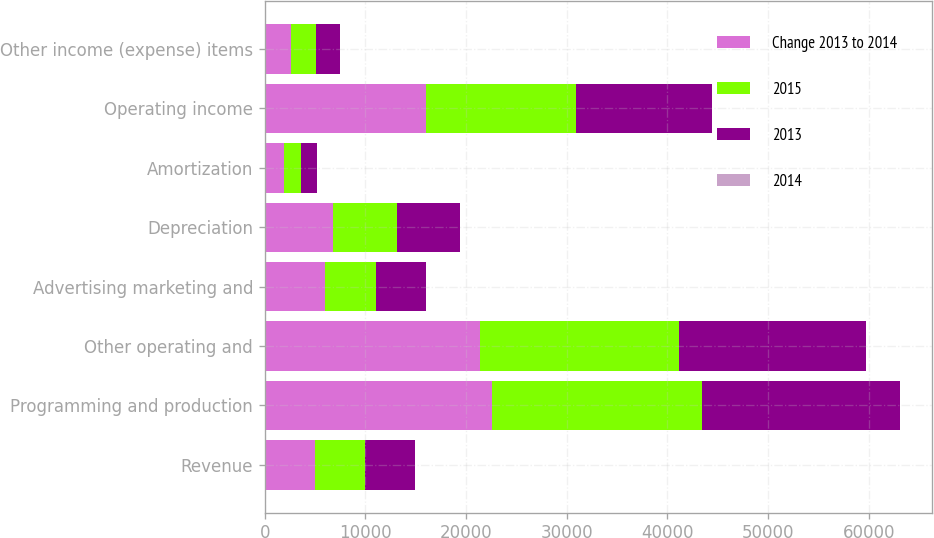Convert chart to OTSL. <chart><loc_0><loc_0><loc_500><loc_500><stacked_bar_chart><ecel><fcel>Revenue<fcel>Programming and production<fcel>Other operating and<fcel>Advertising marketing and<fcel>Depreciation<fcel>Amortization<fcel>Operating income<fcel>Other income (expense) items<nl><fcel>Change 2013 to 2014<fcel>4978<fcel>22550<fcel>21339<fcel>5943<fcel>6781<fcel>1899<fcel>15998<fcel>2626<nl><fcel>2015<fcel>4978<fcel>20912<fcel>19854<fcel>5086<fcel>6337<fcel>1682<fcel>14904<fcel>2439<nl><fcel>2013<fcel>4978<fcel>19670<fcel>18575<fcel>4978<fcel>6254<fcel>1617<fcel>13563<fcel>2448<nl><fcel>2014<fcel>8.3<fcel>7.8<fcel>7.5<fcel>16.8<fcel>7<fcel>12.8<fcel>7.3<fcel>7.7<nl></chart> 